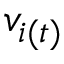Convert formula to latex. <formula><loc_0><loc_0><loc_500><loc_500>v _ { i ( t ) }</formula> 